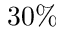Convert formula to latex. <formula><loc_0><loc_0><loc_500><loc_500>3 0 \%</formula> 